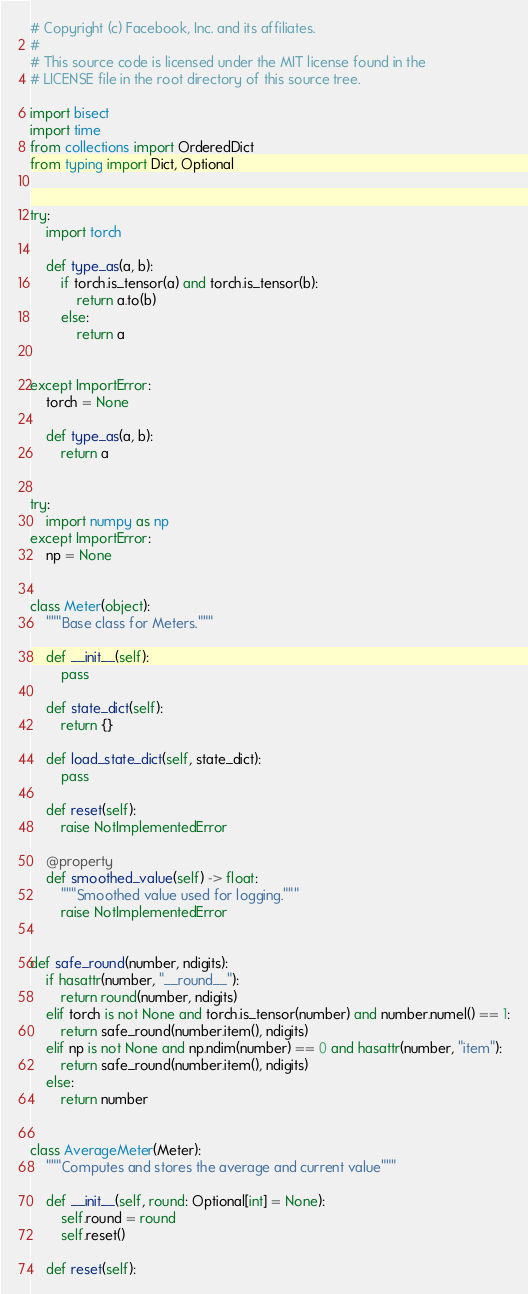Convert code to text. <code><loc_0><loc_0><loc_500><loc_500><_Python_># Copyright (c) Facebook, Inc. and its affiliates.
#
# This source code is licensed under the MIT license found in the
# LICENSE file in the root directory of this source tree.

import bisect
import time
from collections import OrderedDict
from typing import Dict, Optional


try:
    import torch

    def type_as(a, b):
        if torch.is_tensor(a) and torch.is_tensor(b):
            return a.to(b)
        else:
            return a


except ImportError:
    torch = None

    def type_as(a, b):
        return a


try:
    import numpy as np
except ImportError:
    np = None


class Meter(object):
    """Base class for Meters."""

    def __init__(self):
        pass

    def state_dict(self):
        return {}

    def load_state_dict(self, state_dict):
        pass

    def reset(self):
        raise NotImplementedError

    @property
    def smoothed_value(self) -> float:
        """Smoothed value used for logging."""
        raise NotImplementedError


def safe_round(number, ndigits):
    if hasattr(number, "__round__"):
        return round(number, ndigits)
    elif torch is not None and torch.is_tensor(number) and number.numel() == 1:
        return safe_round(number.item(), ndigits)
    elif np is not None and np.ndim(number) == 0 and hasattr(number, "item"):
        return safe_round(number.item(), ndigits)
    else:
        return number


class AverageMeter(Meter):
    """Computes and stores the average and current value"""

    def __init__(self, round: Optional[int] = None):
        self.round = round
        self.reset()

    def reset(self):</code> 